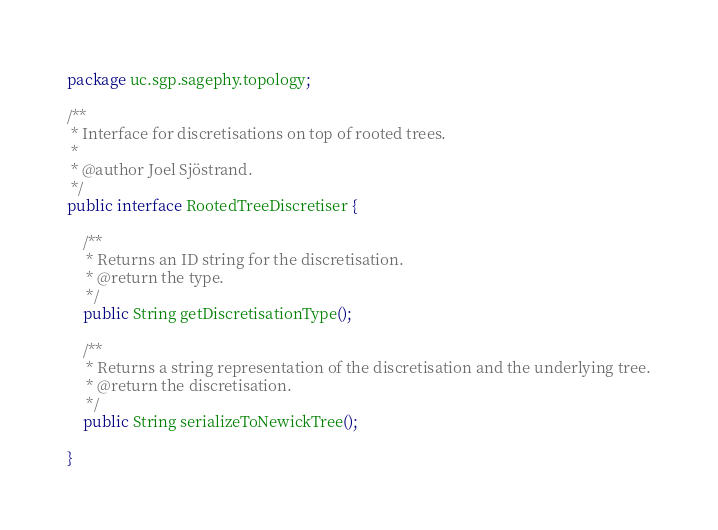<code> <loc_0><loc_0><loc_500><loc_500><_Java_>package uc.sgp.sagephy.topology;

/**
 * Interface for discretisations on top of rooted trees.
 * 
 * @author Joel Sjöstrand.
 */
public interface RootedTreeDiscretiser {

	/**
	 * Returns an ID string for the discretisation.
	 * @return the type.
	 */
	public String getDiscretisationType();
	
	/**
	 * Returns a string representation of the discretisation and the underlying tree.
	 * @return the discretisation.
	 */
	public String serializeToNewickTree();
	
}
</code> 